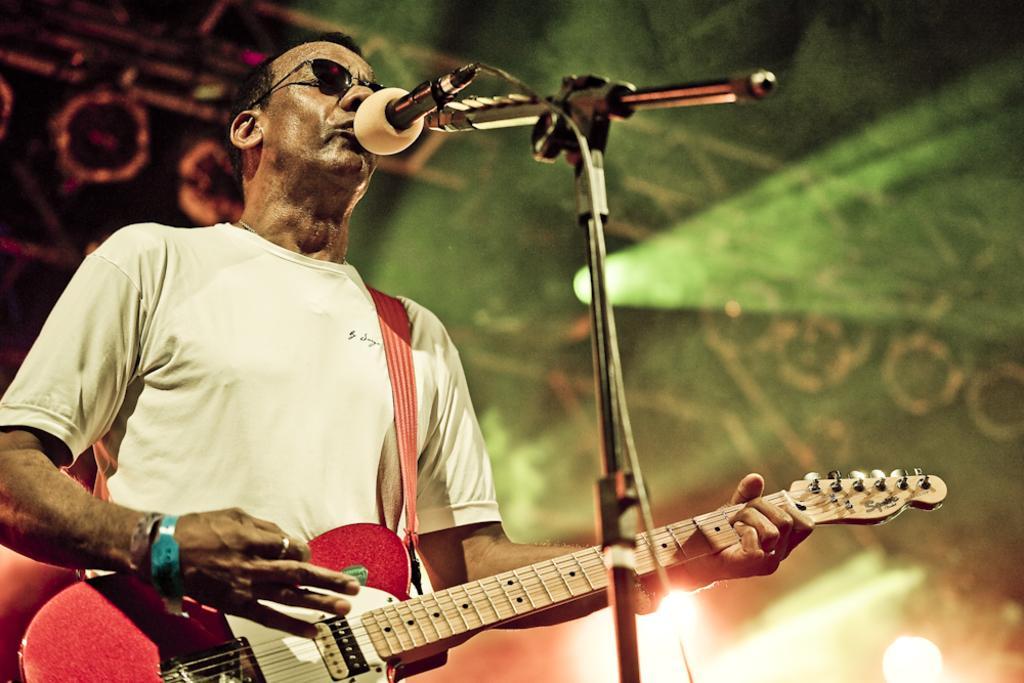Describe this image in one or two sentences. In this picture I can see a person standing, playing guitar and singing in front of the mike. 